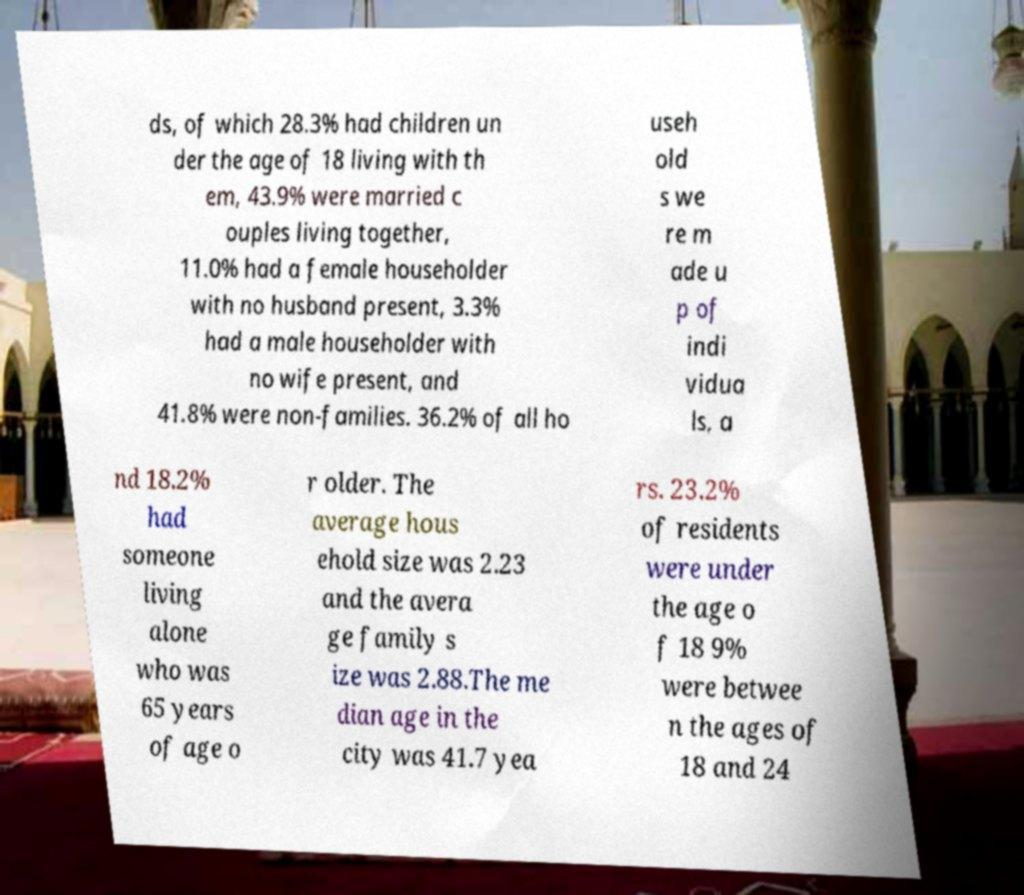Please identify and transcribe the text found in this image. ds, of which 28.3% had children un der the age of 18 living with th em, 43.9% were married c ouples living together, 11.0% had a female householder with no husband present, 3.3% had a male householder with no wife present, and 41.8% were non-families. 36.2% of all ho useh old s we re m ade u p of indi vidua ls, a nd 18.2% had someone living alone who was 65 years of age o r older. The average hous ehold size was 2.23 and the avera ge family s ize was 2.88.The me dian age in the city was 41.7 yea rs. 23.2% of residents were under the age o f 18 9% were betwee n the ages of 18 and 24 